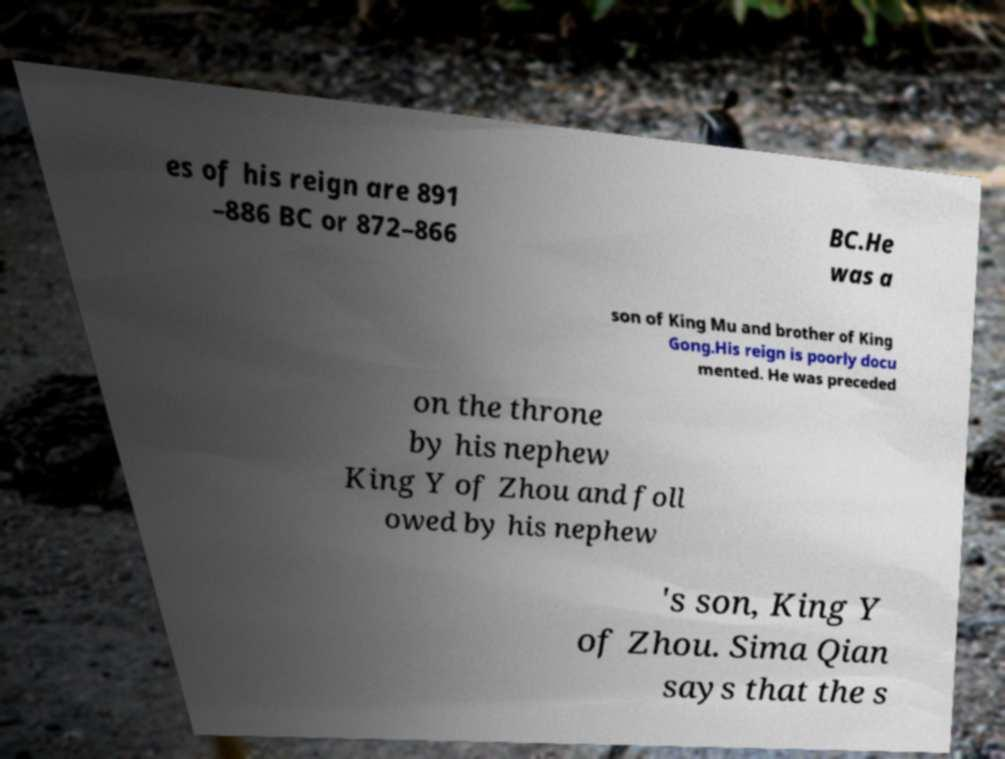Can you accurately transcribe the text from the provided image for me? es of his reign are 891 –886 BC or 872–866 BC.He was a son of King Mu and brother of King Gong.His reign is poorly docu mented. He was preceded on the throne by his nephew King Y of Zhou and foll owed by his nephew 's son, King Y of Zhou. Sima Qian says that the s 